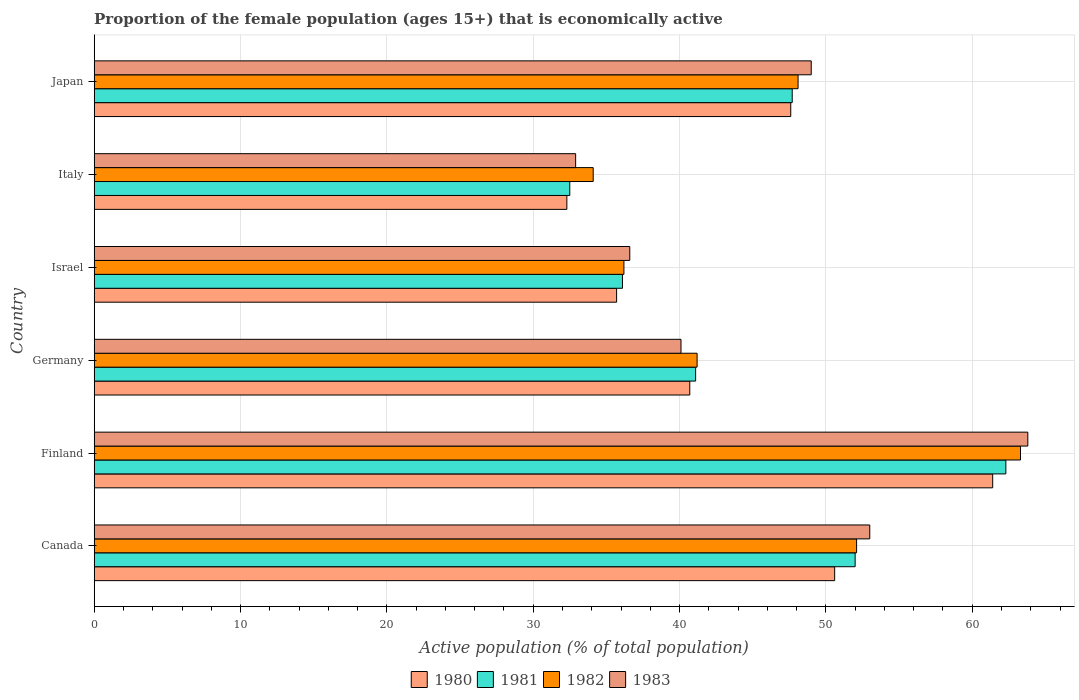How many groups of bars are there?
Give a very brief answer. 6. Are the number of bars per tick equal to the number of legend labels?
Provide a succinct answer. Yes. Are the number of bars on each tick of the Y-axis equal?
Make the answer very short. Yes. How many bars are there on the 6th tick from the top?
Your response must be concise. 4. In how many cases, is the number of bars for a given country not equal to the number of legend labels?
Your answer should be compact. 0. What is the proportion of the female population that is economically active in 1980 in Italy?
Provide a succinct answer. 32.3. Across all countries, what is the maximum proportion of the female population that is economically active in 1981?
Offer a very short reply. 62.3. Across all countries, what is the minimum proportion of the female population that is economically active in 1980?
Your answer should be very brief. 32.3. In which country was the proportion of the female population that is economically active in 1983 minimum?
Give a very brief answer. Italy. What is the total proportion of the female population that is economically active in 1980 in the graph?
Offer a terse response. 268.3. What is the difference between the proportion of the female population that is economically active in 1982 in Germany and that in Italy?
Your answer should be compact. 7.1. What is the difference between the proportion of the female population that is economically active in 1983 in Japan and the proportion of the female population that is economically active in 1980 in Israel?
Make the answer very short. 13.3. What is the average proportion of the female population that is economically active in 1981 per country?
Offer a terse response. 45.28. What is the difference between the proportion of the female population that is economically active in 1981 and proportion of the female population that is economically active in 1980 in Japan?
Your answer should be very brief. 0.1. What is the ratio of the proportion of the female population that is economically active in 1981 in Finland to that in Japan?
Provide a succinct answer. 1.31. What is the difference between the highest and the second highest proportion of the female population that is economically active in 1981?
Make the answer very short. 10.3. What is the difference between the highest and the lowest proportion of the female population that is economically active in 1983?
Ensure brevity in your answer.  30.9. In how many countries, is the proportion of the female population that is economically active in 1981 greater than the average proportion of the female population that is economically active in 1981 taken over all countries?
Offer a terse response. 3. Is the sum of the proportion of the female population that is economically active in 1980 in Finland and Germany greater than the maximum proportion of the female population that is economically active in 1983 across all countries?
Offer a very short reply. Yes. What does the 3rd bar from the bottom in Germany represents?
Keep it short and to the point. 1982. How many bars are there?
Offer a terse response. 24. How many countries are there in the graph?
Provide a succinct answer. 6. What is the difference between two consecutive major ticks on the X-axis?
Provide a succinct answer. 10. Where does the legend appear in the graph?
Your answer should be very brief. Bottom center. What is the title of the graph?
Provide a succinct answer. Proportion of the female population (ages 15+) that is economically active. What is the label or title of the X-axis?
Ensure brevity in your answer.  Active population (% of total population). What is the label or title of the Y-axis?
Your response must be concise. Country. What is the Active population (% of total population) of 1980 in Canada?
Provide a short and direct response. 50.6. What is the Active population (% of total population) in 1982 in Canada?
Give a very brief answer. 52.1. What is the Active population (% of total population) of 1983 in Canada?
Provide a short and direct response. 53. What is the Active population (% of total population) in 1980 in Finland?
Give a very brief answer. 61.4. What is the Active population (% of total population) of 1981 in Finland?
Make the answer very short. 62.3. What is the Active population (% of total population) of 1982 in Finland?
Your answer should be compact. 63.3. What is the Active population (% of total population) in 1983 in Finland?
Your answer should be compact. 63.8. What is the Active population (% of total population) of 1980 in Germany?
Offer a very short reply. 40.7. What is the Active population (% of total population) of 1981 in Germany?
Provide a succinct answer. 41.1. What is the Active population (% of total population) of 1982 in Germany?
Give a very brief answer. 41.2. What is the Active population (% of total population) of 1983 in Germany?
Your answer should be compact. 40.1. What is the Active population (% of total population) of 1980 in Israel?
Make the answer very short. 35.7. What is the Active population (% of total population) in 1981 in Israel?
Your answer should be very brief. 36.1. What is the Active population (% of total population) in 1982 in Israel?
Your answer should be compact. 36.2. What is the Active population (% of total population) of 1983 in Israel?
Make the answer very short. 36.6. What is the Active population (% of total population) of 1980 in Italy?
Ensure brevity in your answer.  32.3. What is the Active population (% of total population) of 1981 in Italy?
Your response must be concise. 32.5. What is the Active population (% of total population) of 1982 in Italy?
Provide a succinct answer. 34.1. What is the Active population (% of total population) of 1983 in Italy?
Provide a succinct answer. 32.9. What is the Active population (% of total population) in 1980 in Japan?
Give a very brief answer. 47.6. What is the Active population (% of total population) of 1981 in Japan?
Ensure brevity in your answer.  47.7. What is the Active population (% of total population) in 1982 in Japan?
Ensure brevity in your answer.  48.1. What is the Active population (% of total population) of 1983 in Japan?
Ensure brevity in your answer.  49. Across all countries, what is the maximum Active population (% of total population) of 1980?
Offer a terse response. 61.4. Across all countries, what is the maximum Active population (% of total population) in 1981?
Offer a terse response. 62.3. Across all countries, what is the maximum Active population (% of total population) of 1982?
Provide a succinct answer. 63.3. Across all countries, what is the maximum Active population (% of total population) in 1983?
Your answer should be very brief. 63.8. Across all countries, what is the minimum Active population (% of total population) in 1980?
Ensure brevity in your answer.  32.3. Across all countries, what is the minimum Active population (% of total population) of 1981?
Your answer should be very brief. 32.5. Across all countries, what is the minimum Active population (% of total population) in 1982?
Offer a very short reply. 34.1. Across all countries, what is the minimum Active population (% of total population) of 1983?
Offer a terse response. 32.9. What is the total Active population (% of total population) in 1980 in the graph?
Make the answer very short. 268.3. What is the total Active population (% of total population) of 1981 in the graph?
Your answer should be very brief. 271.7. What is the total Active population (% of total population) of 1982 in the graph?
Offer a very short reply. 275. What is the total Active population (% of total population) in 1983 in the graph?
Ensure brevity in your answer.  275.4. What is the difference between the Active population (% of total population) in 1980 in Canada and that in Finland?
Ensure brevity in your answer.  -10.8. What is the difference between the Active population (% of total population) of 1982 in Canada and that in Finland?
Offer a terse response. -11.2. What is the difference between the Active population (% of total population) in 1980 in Canada and that in Germany?
Your answer should be very brief. 9.9. What is the difference between the Active population (% of total population) of 1982 in Canada and that in Germany?
Keep it short and to the point. 10.9. What is the difference between the Active population (% of total population) in 1980 in Canada and that in Israel?
Provide a short and direct response. 14.9. What is the difference between the Active population (% of total population) of 1981 in Canada and that in Israel?
Your answer should be compact. 15.9. What is the difference between the Active population (% of total population) of 1980 in Canada and that in Italy?
Provide a succinct answer. 18.3. What is the difference between the Active population (% of total population) in 1982 in Canada and that in Italy?
Your answer should be compact. 18. What is the difference between the Active population (% of total population) in 1983 in Canada and that in Italy?
Provide a short and direct response. 20.1. What is the difference between the Active population (% of total population) of 1980 in Finland and that in Germany?
Offer a terse response. 20.7. What is the difference between the Active population (% of total population) of 1981 in Finland and that in Germany?
Keep it short and to the point. 21.2. What is the difference between the Active population (% of total population) in 1982 in Finland and that in Germany?
Provide a short and direct response. 22.1. What is the difference between the Active population (% of total population) of 1983 in Finland and that in Germany?
Offer a very short reply. 23.7. What is the difference between the Active population (% of total population) of 1980 in Finland and that in Israel?
Keep it short and to the point. 25.7. What is the difference between the Active population (% of total population) in 1981 in Finland and that in Israel?
Offer a very short reply. 26.2. What is the difference between the Active population (% of total population) of 1982 in Finland and that in Israel?
Provide a succinct answer. 27.1. What is the difference between the Active population (% of total population) of 1983 in Finland and that in Israel?
Offer a very short reply. 27.2. What is the difference between the Active population (% of total population) of 1980 in Finland and that in Italy?
Provide a succinct answer. 29.1. What is the difference between the Active population (% of total population) of 1981 in Finland and that in Italy?
Give a very brief answer. 29.8. What is the difference between the Active population (% of total population) in 1982 in Finland and that in Italy?
Keep it short and to the point. 29.2. What is the difference between the Active population (% of total population) of 1983 in Finland and that in Italy?
Keep it short and to the point. 30.9. What is the difference between the Active population (% of total population) of 1981 in Finland and that in Japan?
Give a very brief answer. 14.6. What is the difference between the Active population (% of total population) of 1983 in Finland and that in Japan?
Give a very brief answer. 14.8. What is the difference between the Active population (% of total population) of 1983 in Germany and that in Israel?
Offer a very short reply. 3.5. What is the difference between the Active population (% of total population) in 1980 in Germany and that in Italy?
Provide a succinct answer. 8.4. What is the difference between the Active population (% of total population) in 1981 in Germany and that in Italy?
Ensure brevity in your answer.  8.6. What is the difference between the Active population (% of total population) in 1983 in Germany and that in Italy?
Your response must be concise. 7.2. What is the difference between the Active population (% of total population) of 1981 in Germany and that in Japan?
Make the answer very short. -6.6. What is the difference between the Active population (% of total population) in 1982 in Germany and that in Japan?
Your answer should be compact. -6.9. What is the difference between the Active population (% of total population) of 1980 in Israel and that in Italy?
Give a very brief answer. 3.4. What is the difference between the Active population (% of total population) of 1982 in Israel and that in Italy?
Give a very brief answer. 2.1. What is the difference between the Active population (% of total population) in 1983 in Israel and that in Italy?
Your answer should be compact. 3.7. What is the difference between the Active population (% of total population) in 1980 in Israel and that in Japan?
Your answer should be very brief. -11.9. What is the difference between the Active population (% of total population) of 1981 in Israel and that in Japan?
Make the answer very short. -11.6. What is the difference between the Active population (% of total population) of 1980 in Italy and that in Japan?
Your answer should be compact. -15.3. What is the difference between the Active population (% of total population) of 1981 in Italy and that in Japan?
Your answer should be very brief. -15.2. What is the difference between the Active population (% of total population) of 1983 in Italy and that in Japan?
Provide a succinct answer. -16.1. What is the difference between the Active population (% of total population) of 1980 in Canada and the Active population (% of total population) of 1983 in Finland?
Provide a succinct answer. -13.2. What is the difference between the Active population (% of total population) in 1981 in Canada and the Active population (% of total population) in 1982 in Finland?
Your response must be concise. -11.3. What is the difference between the Active population (% of total population) of 1981 in Canada and the Active population (% of total population) of 1983 in Finland?
Your answer should be very brief. -11.8. What is the difference between the Active population (% of total population) in 1980 in Canada and the Active population (% of total population) in 1981 in Germany?
Your answer should be very brief. 9.5. What is the difference between the Active population (% of total population) in 1980 in Canada and the Active population (% of total population) in 1982 in Germany?
Provide a succinct answer. 9.4. What is the difference between the Active population (% of total population) in 1981 in Canada and the Active population (% of total population) in 1983 in Germany?
Provide a short and direct response. 11.9. What is the difference between the Active population (% of total population) of 1982 in Canada and the Active population (% of total population) of 1983 in Germany?
Provide a short and direct response. 12. What is the difference between the Active population (% of total population) in 1980 in Canada and the Active population (% of total population) in 1981 in Israel?
Give a very brief answer. 14.5. What is the difference between the Active population (% of total population) in 1980 in Canada and the Active population (% of total population) in 1982 in Israel?
Provide a short and direct response. 14.4. What is the difference between the Active population (% of total population) of 1981 in Canada and the Active population (% of total population) of 1983 in Israel?
Ensure brevity in your answer.  15.4. What is the difference between the Active population (% of total population) of 1982 in Canada and the Active population (% of total population) of 1983 in Israel?
Ensure brevity in your answer.  15.5. What is the difference between the Active population (% of total population) in 1980 in Canada and the Active population (% of total population) in 1982 in Italy?
Make the answer very short. 16.5. What is the difference between the Active population (% of total population) in 1980 in Canada and the Active population (% of total population) in 1983 in Italy?
Your answer should be very brief. 17.7. What is the difference between the Active population (% of total population) of 1980 in Canada and the Active population (% of total population) of 1983 in Japan?
Provide a short and direct response. 1.6. What is the difference between the Active population (% of total population) in 1981 in Canada and the Active population (% of total population) in 1982 in Japan?
Give a very brief answer. 3.9. What is the difference between the Active population (% of total population) in 1982 in Canada and the Active population (% of total population) in 1983 in Japan?
Ensure brevity in your answer.  3.1. What is the difference between the Active population (% of total population) in 1980 in Finland and the Active population (% of total population) in 1981 in Germany?
Offer a terse response. 20.3. What is the difference between the Active population (% of total population) of 1980 in Finland and the Active population (% of total population) of 1982 in Germany?
Provide a short and direct response. 20.2. What is the difference between the Active population (% of total population) of 1980 in Finland and the Active population (% of total population) of 1983 in Germany?
Offer a terse response. 21.3. What is the difference between the Active population (% of total population) of 1981 in Finland and the Active population (% of total population) of 1982 in Germany?
Offer a terse response. 21.1. What is the difference between the Active population (% of total population) of 1981 in Finland and the Active population (% of total population) of 1983 in Germany?
Give a very brief answer. 22.2. What is the difference between the Active population (% of total population) in 1982 in Finland and the Active population (% of total population) in 1983 in Germany?
Offer a terse response. 23.2. What is the difference between the Active population (% of total population) in 1980 in Finland and the Active population (% of total population) in 1981 in Israel?
Provide a short and direct response. 25.3. What is the difference between the Active population (% of total population) in 1980 in Finland and the Active population (% of total population) in 1982 in Israel?
Provide a succinct answer. 25.2. What is the difference between the Active population (% of total population) of 1980 in Finland and the Active population (% of total population) of 1983 in Israel?
Keep it short and to the point. 24.8. What is the difference between the Active population (% of total population) of 1981 in Finland and the Active population (% of total population) of 1982 in Israel?
Offer a very short reply. 26.1. What is the difference between the Active population (% of total population) in 1981 in Finland and the Active population (% of total population) in 1983 in Israel?
Your answer should be very brief. 25.7. What is the difference between the Active population (% of total population) in 1982 in Finland and the Active population (% of total population) in 1983 in Israel?
Make the answer very short. 26.7. What is the difference between the Active population (% of total population) of 1980 in Finland and the Active population (% of total population) of 1981 in Italy?
Offer a very short reply. 28.9. What is the difference between the Active population (% of total population) of 1980 in Finland and the Active population (% of total population) of 1982 in Italy?
Offer a terse response. 27.3. What is the difference between the Active population (% of total population) of 1981 in Finland and the Active population (% of total population) of 1982 in Italy?
Your answer should be very brief. 28.2. What is the difference between the Active population (% of total population) of 1981 in Finland and the Active population (% of total population) of 1983 in Italy?
Offer a terse response. 29.4. What is the difference between the Active population (% of total population) of 1982 in Finland and the Active population (% of total population) of 1983 in Italy?
Your answer should be very brief. 30.4. What is the difference between the Active population (% of total population) of 1980 in Finland and the Active population (% of total population) of 1981 in Japan?
Your answer should be very brief. 13.7. What is the difference between the Active population (% of total population) of 1980 in Finland and the Active population (% of total population) of 1983 in Japan?
Offer a very short reply. 12.4. What is the difference between the Active population (% of total population) in 1982 in Finland and the Active population (% of total population) in 1983 in Japan?
Provide a succinct answer. 14.3. What is the difference between the Active population (% of total population) of 1980 in Germany and the Active population (% of total population) of 1982 in Israel?
Your answer should be compact. 4.5. What is the difference between the Active population (% of total population) in 1980 in Germany and the Active population (% of total population) in 1983 in Israel?
Offer a very short reply. 4.1. What is the difference between the Active population (% of total population) of 1981 in Germany and the Active population (% of total population) of 1982 in Israel?
Offer a very short reply. 4.9. What is the difference between the Active population (% of total population) of 1981 in Germany and the Active population (% of total population) of 1983 in Israel?
Your answer should be compact. 4.5. What is the difference between the Active population (% of total population) of 1982 in Germany and the Active population (% of total population) of 1983 in Israel?
Ensure brevity in your answer.  4.6. What is the difference between the Active population (% of total population) of 1980 in Germany and the Active population (% of total population) of 1982 in Italy?
Offer a terse response. 6.6. What is the difference between the Active population (% of total population) in 1980 in Germany and the Active population (% of total population) in 1983 in Italy?
Ensure brevity in your answer.  7.8. What is the difference between the Active population (% of total population) of 1981 in Germany and the Active population (% of total population) of 1983 in Italy?
Provide a succinct answer. 8.2. What is the difference between the Active population (% of total population) of 1982 in Germany and the Active population (% of total population) of 1983 in Japan?
Offer a terse response. -7.8. What is the difference between the Active population (% of total population) in 1980 in Israel and the Active population (% of total population) in 1981 in Italy?
Offer a terse response. 3.2. What is the difference between the Active population (% of total population) in 1980 in Israel and the Active population (% of total population) in 1982 in Italy?
Your answer should be compact. 1.6. What is the difference between the Active population (% of total population) in 1980 in Israel and the Active population (% of total population) in 1983 in Italy?
Offer a very short reply. 2.8. What is the difference between the Active population (% of total population) in 1981 in Israel and the Active population (% of total population) in 1982 in Italy?
Give a very brief answer. 2. What is the difference between the Active population (% of total population) in 1981 in Israel and the Active population (% of total population) in 1983 in Italy?
Give a very brief answer. 3.2. What is the difference between the Active population (% of total population) of 1980 in Israel and the Active population (% of total population) of 1983 in Japan?
Make the answer very short. -13.3. What is the difference between the Active population (% of total population) in 1980 in Italy and the Active population (% of total population) in 1981 in Japan?
Ensure brevity in your answer.  -15.4. What is the difference between the Active population (% of total population) of 1980 in Italy and the Active population (% of total population) of 1982 in Japan?
Offer a terse response. -15.8. What is the difference between the Active population (% of total population) in 1980 in Italy and the Active population (% of total population) in 1983 in Japan?
Give a very brief answer. -16.7. What is the difference between the Active population (% of total population) of 1981 in Italy and the Active population (% of total population) of 1982 in Japan?
Your answer should be compact. -15.6. What is the difference between the Active population (% of total population) in 1981 in Italy and the Active population (% of total population) in 1983 in Japan?
Keep it short and to the point. -16.5. What is the difference between the Active population (% of total population) of 1982 in Italy and the Active population (% of total population) of 1983 in Japan?
Provide a short and direct response. -14.9. What is the average Active population (% of total population) in 1980 per country?
Ensure brevity in your answer.  44.72. What is the average Active population (% of total population) in 1981 per country?
Your response must be concise. 45.28. What is the average Active population (% of total population) in 1982 per country?
Make the answer very short. 45.83. What is the average Active population (% of total population) of 1983 per country?
Offer a terse response. 45.9. What is the difference between the Active population (% of total population) of 1980 and Active population (% of total population) of 1981 in Canada?
Make the answer very short. -1.4. What is the difference between the Active population (% of total population) of 1981 and Active population (% of total population) of 1982 in Canada?
Keep it short and to the point. -0.1. What is the difference between the Active population (% of total population) of 1982 and Active population (% of total population) of 1983 in Canada?
Make the answer very short. -0.9. What is the difference between the Active population (% of total population) in 1980 and Active population (% of total population) in 1983 in Finland?
Keep it short and to the point. -2.4. What is the difference between the Active population (% of total population) of 1982 and Active population (% of total population) of 1983 in Finland?
Your answer should be very brief. -0.5. What is the difference between the Active population (% of total population) of 1980 and Active population (% of total population) of 1981 in Germany?
Make the answer very short. -0.4. What is the difference between the Active population (% of total population) in 1980 and Active population (% of total population) in 1982 in Germany?
Make the answer very short. -0.5. What is the difference between the Active population (% of total population) in 1980 and Active population (% of total population) in 1983 in Germany?
Your answer should be compact. 0.6. What is the difference between the Active population (% of total population) in 1981 and Active population (% of total population) in 1982 in Germany?
Your response must be concise. -0.1. What is the difference between the Active population (% of total population) of 1982 and Active population (% of total population) of 1983 in Germany?
Your answer should be compact. 1.1. What is the difference between the Active population (% of total population) of 1981 and Active population (% of total population) of 1983 in Israel?
Keep it short and to the point. -0.5. What is the difference between the Active population (% of total population) of 1980 and Active population (% of total population) of 1981 in Italy?
Offer a very short reply. -0.2. What is the difference between the Active population (% of total population) in 1980 and Active population (% of total population) in 1982 in Italy?
Keep it short and to the point. -1.8. What is the difference between the Active population (% of total population) in 1980 and Active population (% of total population) in 1983 in Italy?
Keep it short and to the point. -0.6. What is the difference between the Active population (% of total population) of 1981 and Active population (% of total population) of 1982 in Italy?
Your response must be concise. -1.6. What is the difference between the Active population (% of total population) of 1981 and Active population (% of total population) of 1982 in Japan?
Your response must be concise. -0.4. What is the ratio of the Active population (% of total population) of 1980 in Canada to that in Finland?
Provide a short and direct response. 0.82. What is the ratio of the Active population (% of total population) of 1981 in Canada to that in Finland?
Make the answer very short. 0.83. What is the ratio of the Active population (% of total population) in 1982 in Canada to that in Finland?
Offer a terse response. 0.82. What is the ratio of the Active population (% of total population) in 1983 in Canada to that in Finland?
Ensure brevity in your answer.  0.83. What is the ratio of the Active population (% of total population) in 1980 in Canada to that in Germany?
Offer a terse response. 1.24. What is the ratio of the Active population (% of total population) in 1981 in Canada to that in Germany?
Your response must be concise. 1.27. What is the ratio of the Active population (% of total population) in 1982 in Canada to that in Germany?
Provide a succinct answer. 1.26. What is the ratio of the Active population (% of total population) of 1983 in Canada to that in Germany?
Give a very brief answer. 1.32. What is the ratio of the Active population (% of total population) of 1980 in Canada to that in Israel?
Offer a terse response. 1.42. What is the ratio of the Active population (% of total population) in 1981 in Canada to that in Israel?
Keep it short and to the point. 1.44. What is the ratio of the Active population (% of total population) in 1982 in Canada to that in Israel?
Provide a succinct answer. 1.44. What is the ratio of the Active population (% of total population) of 1983 in Canada to that in Israel?
Make the answer very short. 1.45. What is the ratio of the Active population (% of total population) of 1980 in Canada to that in Italy?
Offer a terse response. 1.57. What is the ratio of the Active population (% of total population) of 1982 in Canada to that in Italy?
Offer a terse response. 1.53. What is the ratio of the Active population (% of total population) in 1983 in Canada to that in Italy?
Offer a terse response. 1.61. What is the ratio of the Active population (% of total population) of 1980 in Canada to that in Japan?
Keep it short and to the point. 1.06. What is the ratio of the Active population (% of total population) of 1981 in Canada to that in Japan?
Your answer should be very brief. 1.09. What is the ratio of the Active population (% of total population) of 1982 in Canada to that in Japan?
Offer a terse response. 1.08. What is the ratio of the Active population (% of total population) of 1983 in Canada to that in Japan?
Ensure brevity in your answer.  1.08. What is the ratio of the Active population (% of total population) of 1980 in Finland to that in Germany?
Provide a succinct answer. 1.51. What is the ratio of the Active population (% of total population) of 1981 in Finland to that in Germany?
Provide a succinct answer. 1.52. What is the ratio of the Active population (% of total population) in 1982 in Finland to that in Germany?
Make the answer very short. 1.54. What is the ratio of the Active population (% of total population) in 1983 in Finland to that in Germany?
Keep it short and to the point. 1.59. What is the ratio of the Active population (% of total population) in 1980 in Finland to that in Israel?
Keep it short and to the point. 1.72. What is the ratio of the Active population (% of total population) in 1981 in Finland to that in Israel?
Offer a very short reply. 1.73. What is the ratio of the Active population (% of total population) in 1982 in Finland to that in Israel?
Provide a short and direct response. 1.75. What is the ratio of the Active population (% of total population) in 1983 in Finland to that in Israel?
Ensure brevity in your answer.  1.74. What is the ratio of the Active population (% of total population) in 1980 in Finland to that in Italy?
Offer a terse response. 1.9. What is the ratio of the Active population (% of total population) of 1981 in Finland to that in Italy?
Provide a succinct answer. 1.92. What is the ratio of the Active population (% of total population) in 1982 in Finland to that in Italy?
Your response must be concise. 1.86. What is the ratio of the Active population (% of total population) in 1983 in Finland to that in Italy?
Your answer should be very brief. 1.94. What is the ratio of the Active population (% of total population) in 1980 in Finland to that in Japan?
Your response must be concise. 1.29. What is the ratio of the Active population (% of total population) of 1981 in Finland to that in Japan?
Provide a short and direct response. 1.31. What is the ratio of the Active population (% of total population) in 1982 in Finland to that in Japan?
Offer a terse response. 1.32. What is the ratio of the Active population (% of total population) of 1983 in Finland to that in Japan?
Offer a very short reply. 1.3. What is the ratio of the Active population (% of total population) of 1980 in Germany to that in Israel?
Offer a very short reply. 1.14. What is the ratio of the Active population (% of total population) in 1981 in Germany to that in Israel?
Make the answer very short. 1.14. What is the ratio of the Active population (% of total population) in 1982 in Germany to that in Israel?
Ensure brevity in your answer.  1.14. What is the ratio of the Active population (% of total population) of 1983 in Germany to that in Israel?
Your answer should be compact. 1.1. What is the ratio of the Active population (% of total population) of 1980 in Germany to that in Italy?
Provide a short and direct response. 1.26. What is the ratio of the Active population (% of total population) in 1981 in Germany to that in Italy?
Offer a terse response. 1.26. What is the ratio of the Active population (% of total population) in 1982 in Germany to that in Italy?
Ensure brevity in your answer.  1.21. What is the ratio of the Active population (% of total population) in 1983 in Germany to that in Italy?
Your answer should be very brief. 1.22. What is the ratio of the Active population (% of total population) in 1980 in Germany to that in Japan?
Keep it short and to the point. 0.85. What is the ratio of the Active population (% of total population) in 1981 in Germany to that in Japan?
Your answer should be very brief. 0.86. What is the ratio of the Active population (% of total population) in 1982 in Germany to that in Japan?
Your answer should be very brief. 0.86. What is the ratio of the Active population (% of total population) in 1983 in Germany to that in Japan?
Provide a short and direct response. 0.82. What is the ratio of the Active population (% of total population) in 1980 in Israel to that in Italy?
Make the answer very short. 1.11. What is the ratio of the Active population (% of total population) of 1981 in Israel to that in Italy?
Your answer should be very brief. 1.11. What is the ratio of the Active population (% of total population) of 1982 in Israel to that in Italy?
Provide a short and direct response. 1.06. What is the ratio of the Active population (% of total population) in 1983 in Israel to that in Italy?
Offer a very short reply. 1.11. What is the ratio of the Active population (% of total population) in 1981 in Israel to that in Japan?
Ensure brevity in your answer.  0.76. What is the ratio of the Active population (% of total population) of 1982 in Israel to that in Japan?
Offer a very short reply. 0.75. What is the ratio of the Active population (% of total population) of 1983 in Israel to that in Japan?
Your answer should be compact. 0.75. What is the ratio of the Active population (% of total population) of 1980 in Italy to that in Japan?
Your answer should be compact. 0.68. What is the ratio of the Active population (% of total population) of 1981 in Italy to that in Japan?
Your answer should be very brief. 0.68. What is the ratio of the Active population (% of total population) in 1982 in Italy to that in Japan?
Your answer should be very brief. 0.71. What is the ratio of the Active population (% of total population) of 1983 in Italy to that in Japan?
Ensure brevity in your answer.  0.67. What is the difference between the highest and the second highest Active population (% of total population) of 1983?
Provide a short and direct response. 10.8. What is the difference between the highest and the lowest Active population (% of total population) in 1980?
Your response must be concise. 29.1. What is the difference between the highest and the lowest Active population (% of total population) in 1981?
Ensure brevity in your answer.  29.8. What is the difference between the highest and the lowest Active population (% of total population) in 1982?
Your answer should be very brief. 29.2. What is the difference between the highest and the lowest Active population (% of total population) of 1983?
Provide a succinct answer. 30.9. 